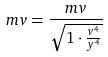Convert formula to latex. <formula><loc_0><loc_0><loc_500><loc_500>m v = \frac { m v } { \sqrt { 1 \cdot \frac { v ^ { 4 } } { y ^ { 4 } } } }</formula> 